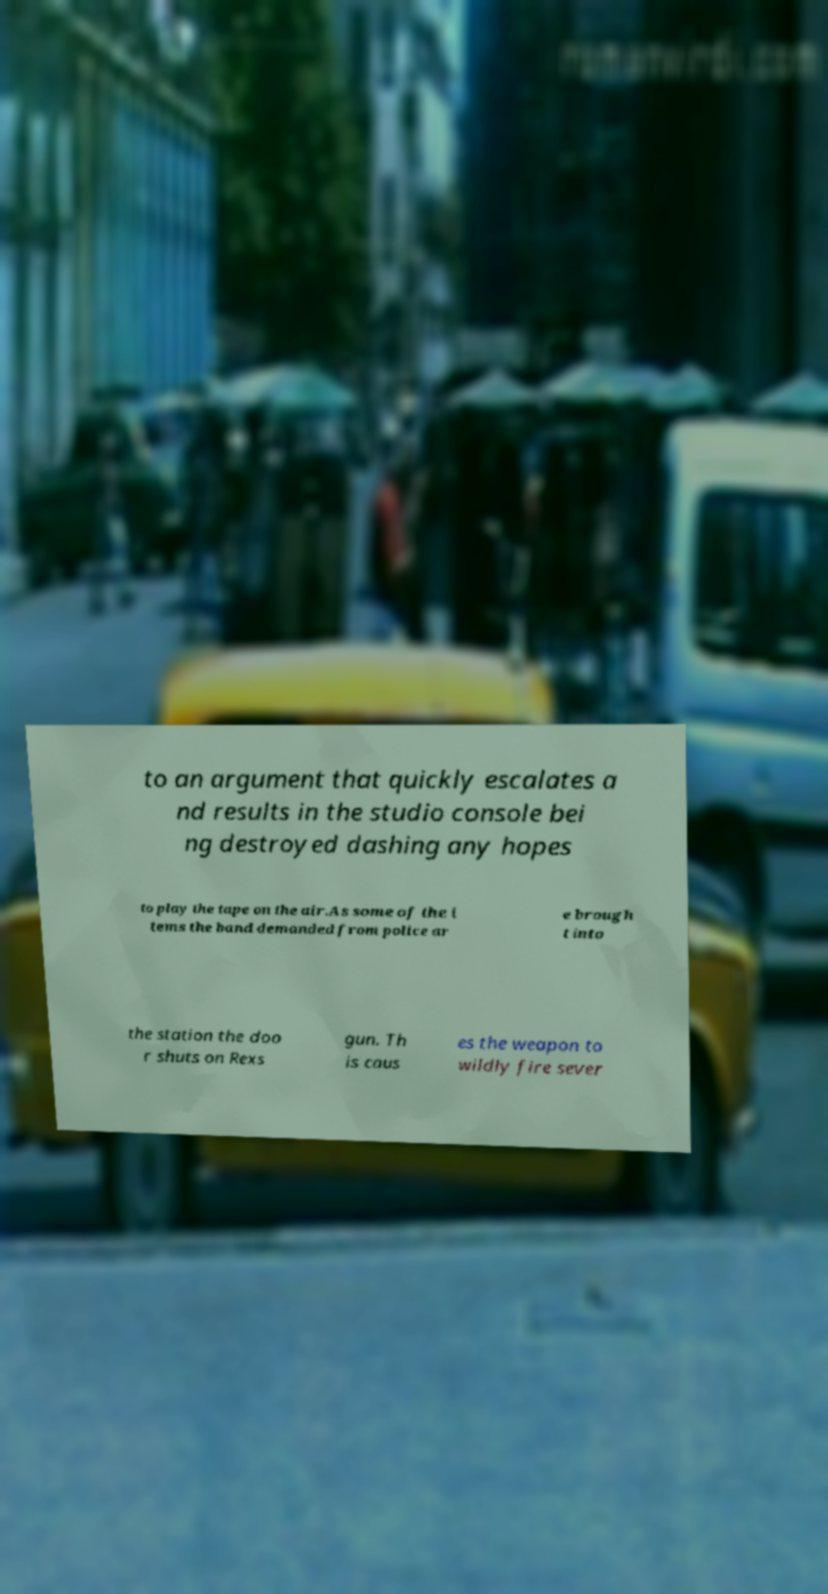Could you assist in decoding the text presented in this image and type it out clearly? to an argument that quickly escalates a nd results in the studio console bei ng destroyed dashing any hopes to play the tape on the air.As some of the i tems the band demanded from police ar e brough t into the station the doo r shuts on Rexs gun. Th is caus es the weapon to wildly fire sever 